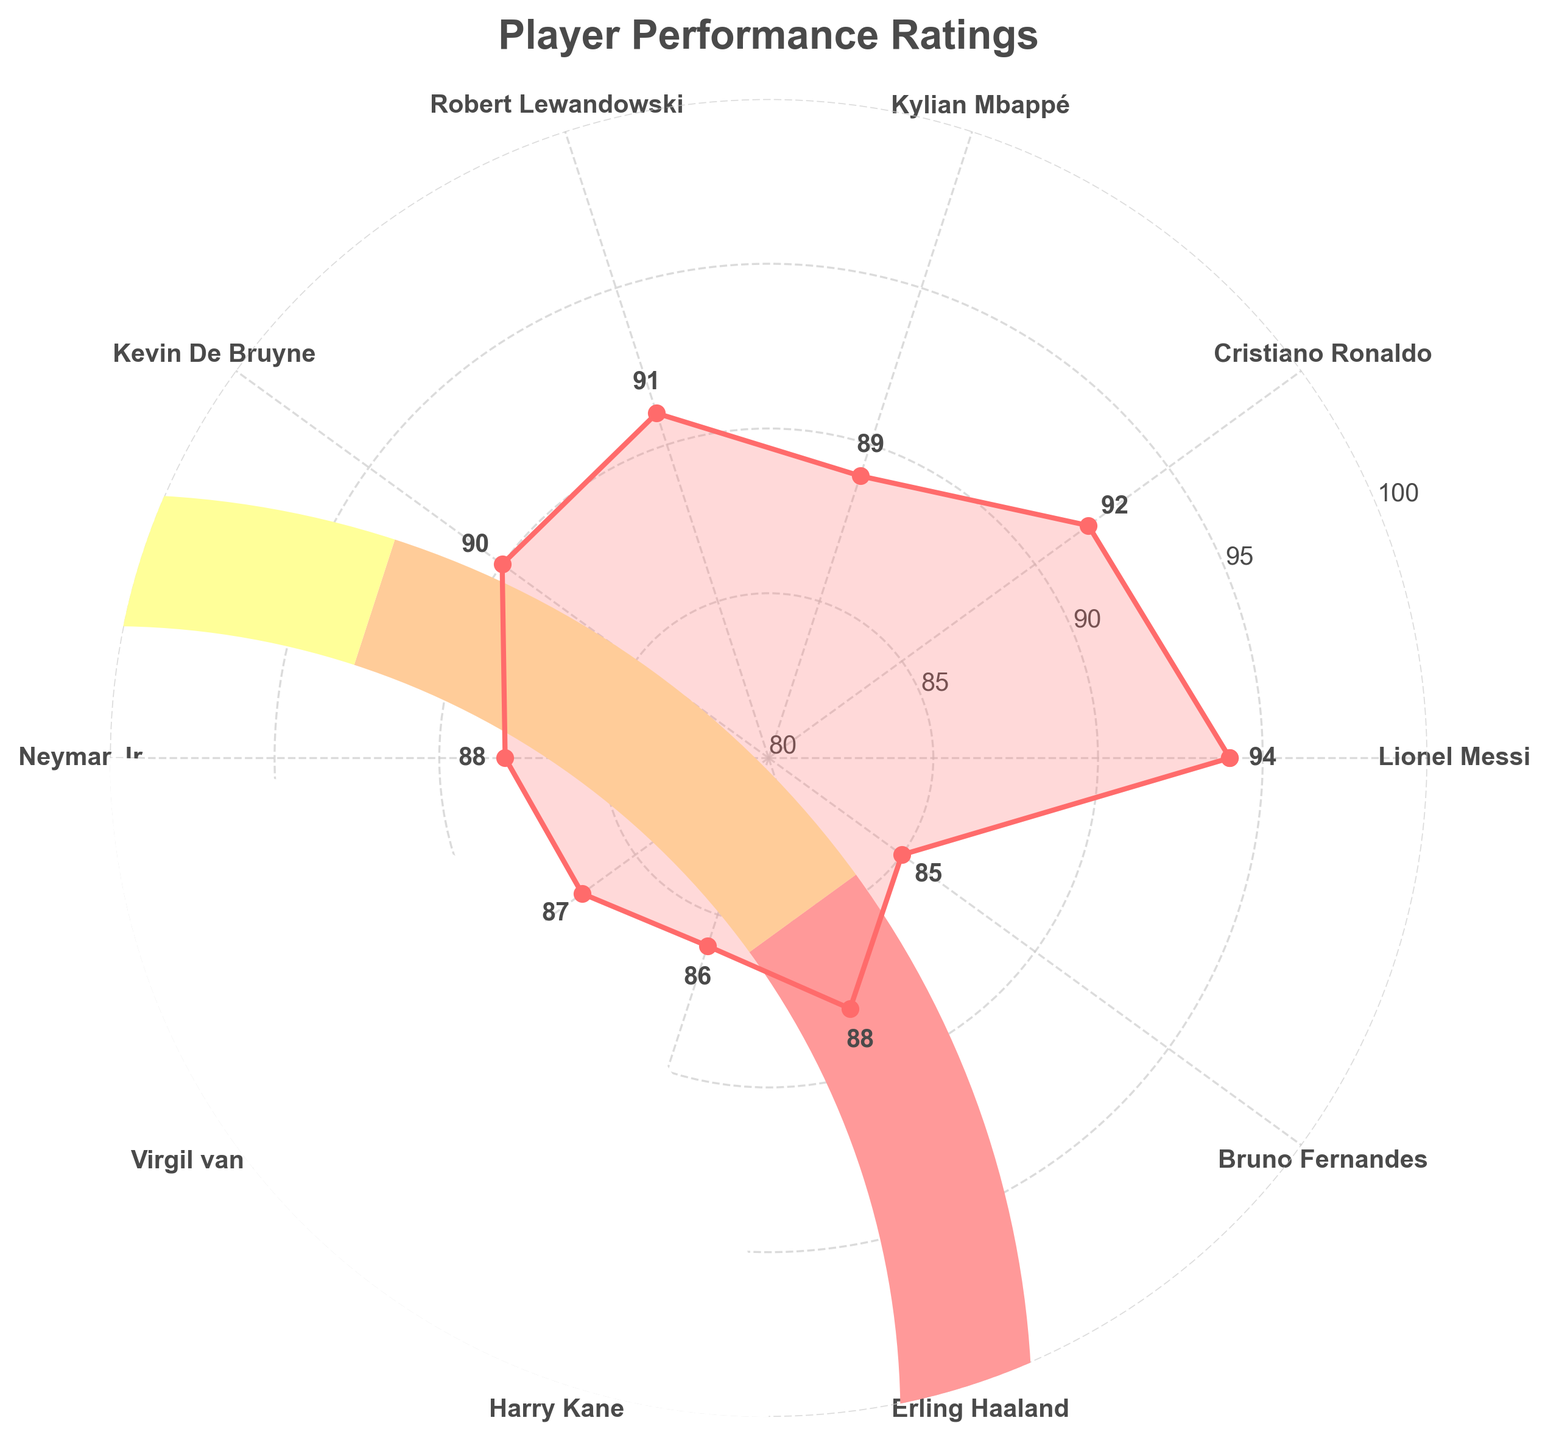Which player has the highest performance rating? The dotted line with the highest value on the chart indicates Lionel Messi's rating, which is 94.
Answer: Lionel Messi What is the performance rating of Kylian Mbappé? Locate Kylian Mbappé on the chart and find the corresponding number near his name.
Answer: 89 Who has a higher rating, Cristiano Ronaldo or Kevin De Bruyne? Find the ratings for both Cristiano Ronaldo and Kevin De Bruyne on the chart and compare them. Cristiano Ronaldo has a rating of 92, while Kevin De Bruyne has a rating of 90.
Answer: Cristiano Ronaldo What is the difference in ratings between Harry Kane and Neymar Jr.? Find the ratings for both Harry Kane and Neymar Jr. on the chart (86 and 88, respectively) and subtract them. 88 - 86 = 2.
Answer: 2 How many players have a rating above 90? Count the players with ratings above 90 on the chart. They are Lionel Messi (94), Cristiano Ronaldo (92), Robert Lewandowski (91), and Kevin De Bruyne (90).
Answer: 4 What is the average performance rating of all players? Add up all the ratings from the chart: 94, 92, 89, 91, 90, 88, 87, 86, 88, 85. Total = 890. Then, divide by the number of players, 10. 890 / 10 = 89.
Answer: 89 Which player has the lowest rating? Find the player with the lowest value on the chart, which is Bruno Fernandes with a rating of 85.
Answer: Bruno Fernandes What is the median performance rating of these players? Arrange the ratings in ascending order: 85, 86, 87, 88, 88, 89, 90, 91, 92, 94. The median is the average of the 5th and 6th values, ((88 + 89) / 2) = 88.5.
Answer: 88.5 Are there any two players with the same performance rating? If so, who are they? Check the chart for duplicate ratings, and it is found that Neymar Jr. and Erling Haaland both have a rating of 88.
Answer: Neymar Jr. and Erling Haaland 